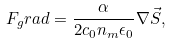Convert formula to latex. <formula><loc_0><loc_0><loc_500><loc_500>F _ { g } r a d = \frac { \alpha } { 2 c _ { 0 } n _ { m } \epsilon _ { 0 } } \nabla \vec { S } ,</formula> 